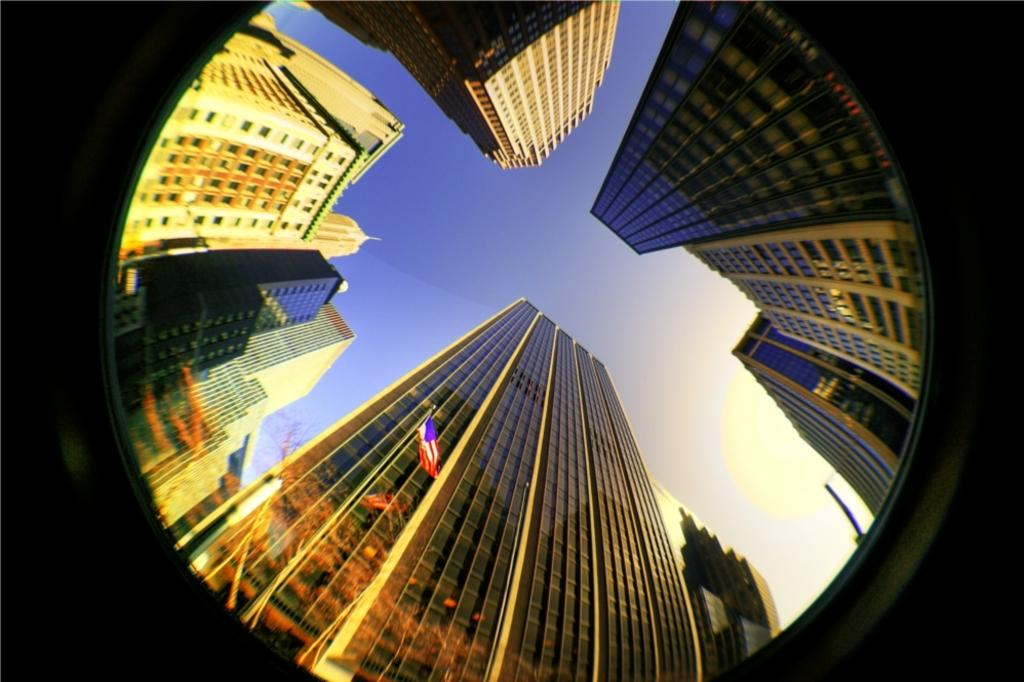What is located in the foreground of the image? There is a mirror in the foreground of the image. What can be seen through the mirror? Buildings, a pole, a flag, and the sky are visible through the mirror. How many distinct elements can be seen through the mirror? Five distinct elements can be seen through the mirror: buildings, a pole, a flag, and the sky. What type of substance is being tasted by the person in the image? There is no person present in the image, and therefore no substance can be tasted. What flavor of ray is visible in the image? There is no ray present in the image, and therefore no flavor can be determined. 